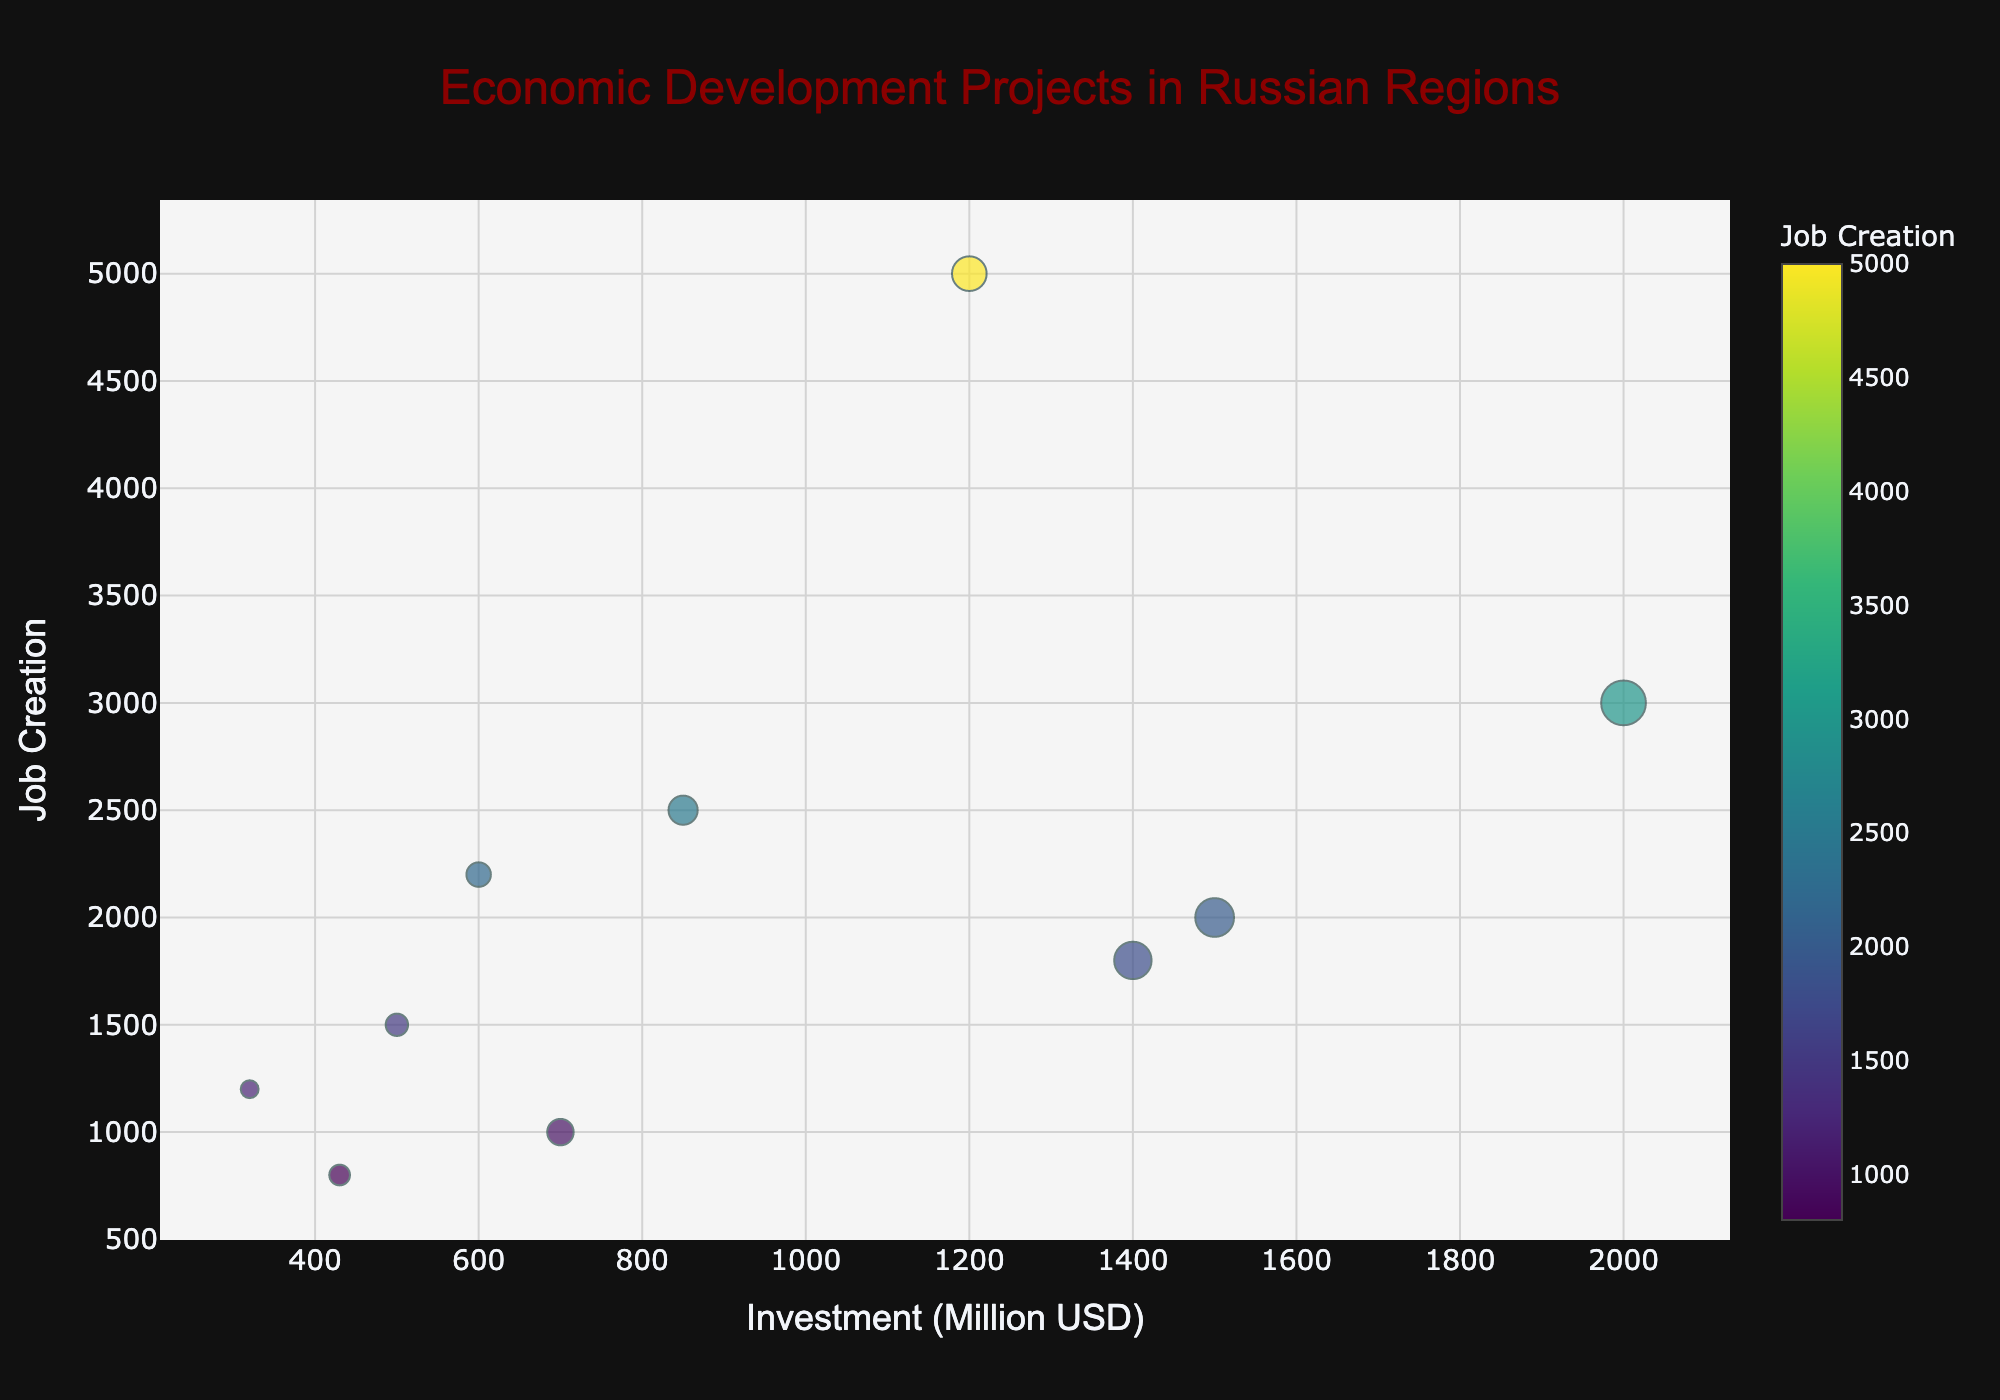How many data points are there in the figure? Each region has one bubble representing a project. The total number of regions or projects will give us the number of data points. Counting the regions listed: Moscow, Saint Petersburg, Tatarstan, Sakhalin, Krasnoyarsk, Sverdlovsk, Rostov, Novosibirsk, Vladivostok, Khabarovsk, we get ten data points.
Answer: 10 Which project has the highest investment? Look at the x-axis representing the investment amounts and find the bubble farthest to the right. Saint Petersburg's Lakhta Center Development has the highest investment at 2000 million USD.
Answer: Lakhta Center Development Which project creates the most jobs? Look at the y-axis representing job creation and find the highest bubble. Moscow's Skolkovo Innovation Center, with 5000 jobs, creates the most jobs.
Answer: Skolkovo Innovation Center Which two projects create the same number of jobs? Locate bubbles aligning horizontally on the y-axis. Saint Petersburg's Lakhta Center Development and Novosibirsk's Science Park both create 2200 jobs.
Answer: Lakhta Center Development and Science Park How many jobs does the Krasnoyarsk Technopark create? Find the bubble labeled as Krasnoyarsk Technopark and look at its y-axis position. The y-axis value should correspond to its job creation, which is 1200.
Answer: 1200 Which project has the smallest investment? Look at the x-axis and find the bubble positioned furthest left. Krasnoyarsk Technopark, with 320 million USD investment, is the smallest.
Answer: Krasnoyarsk Technopark What’s the difference in job creation between Vostochny Spaceport Expansion and Yekaterinburg Metro Expansion? Find the y-axis positions for both projects: Vostochny Spaceport (1800) and Yekaterinburg Metro (1500). Subtracting these values gives us 1800 - 1500 = 300 jobs.
Answer: 300 Which project has a bigger bubble size: IT Park Kazan or Rostov Port Modernization? Bubble size is proportional to the square root of the investment amount. IT Park Kazan has an investment of 850 million USD, and Rostov Port Modernization 430 million USD. Thus, IT Park Kazan will have a larger bubble.
Answer: IT Park Kazan Are there any projects with a similar investment but significantly different job creation? Compare bubbles with close x-axis values but significantly different y-axis values. For example, Khabarovsk Airport Modernization (700 million USD, 1000 jobs) and Novosibirsk Science Park (600 million USD, 2200 jobs) have similar investments but create very different job numbers.
Answer: Khabarovsk Airport Modernization and Novosibirsk Science Park Which project’s bubble is the dark green color? Bubble color represents job creation with a Viridis color scale. Darker green usually indicates fewer jobs. Krasnoyarsk Technopark (1200 jobs) is a suitable candidate as that's a mid-range color.
Answer: Krasnoyarsk Technopark 